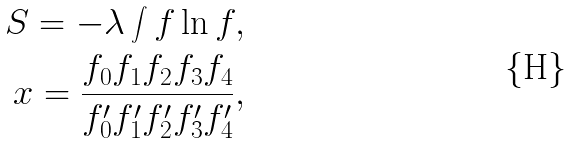<formula> <loc_0><loc_0><loc_500><loc_500>S = - \lambda \int f \ln f , \\ x = \frac { f _ { 0 } f _ { 1 } f _ { 2 } f _ { 3 } f _ { 4 } } { f _ { 0 } ^ { \prime } f _ { 1 } ^ { \prime } f _ { 2 } ^ { \prime } f _ { 3 } ^ { \prime } f _ { 4 } ^ { \prime } } ,</formula> 